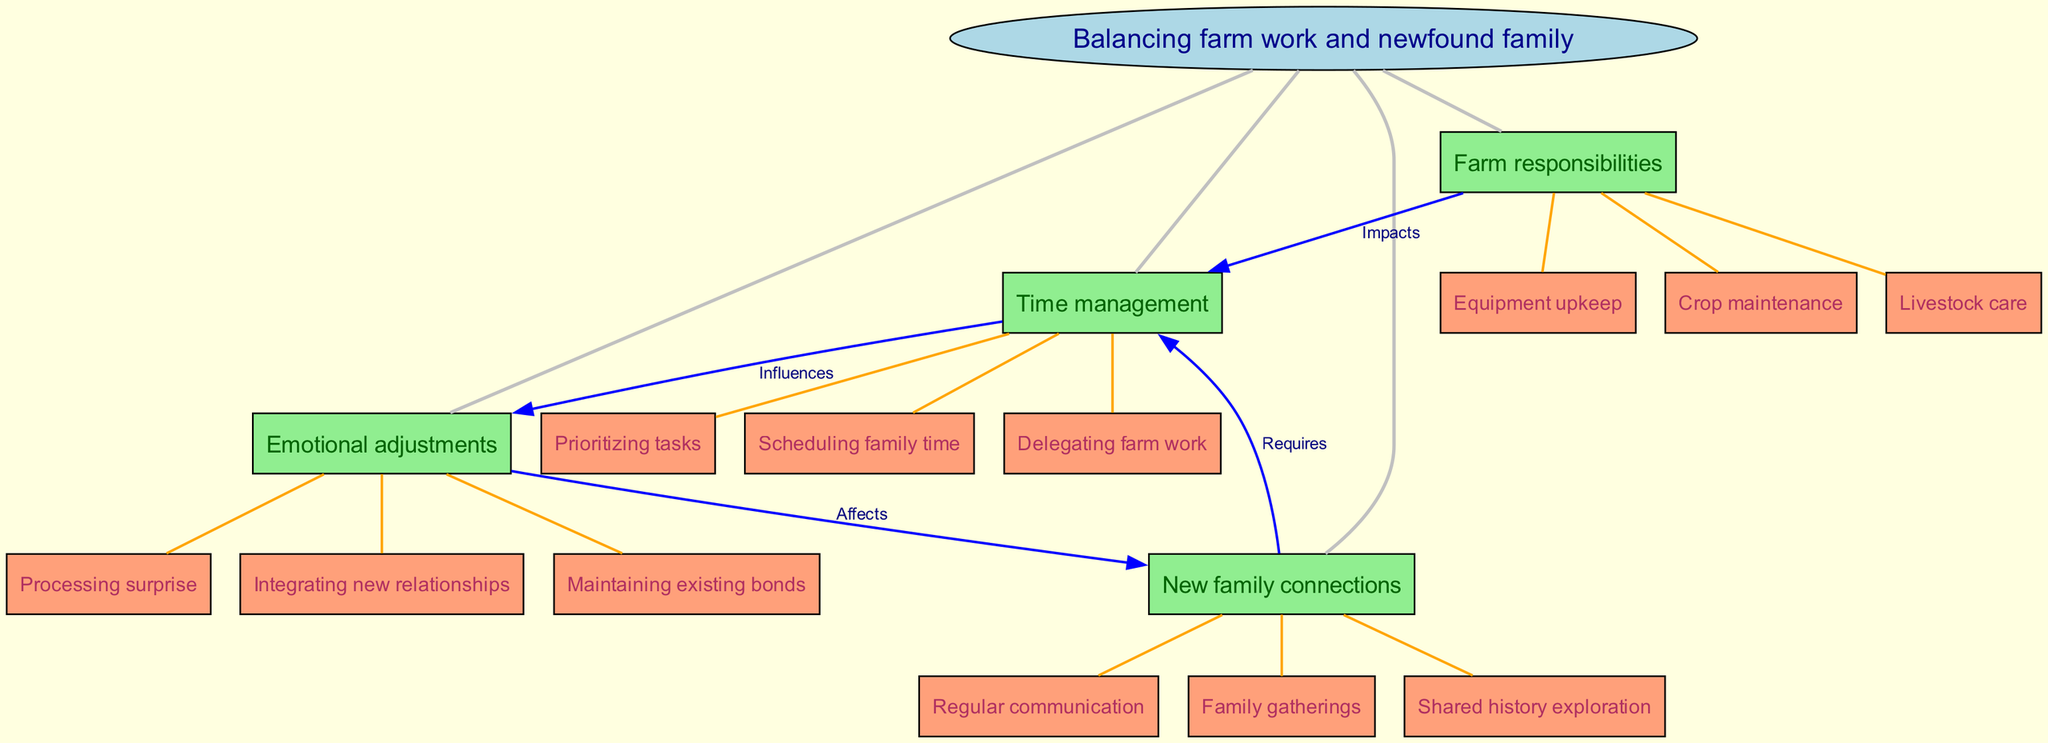What is the central concept of the diagram? The central concept is labeled "Balancing farm work and newfound family." This is specifically the node that is in the center of the diagram, connecting to the main themes of the concept map.
Answer: Balancing farm work and newfound family How many main nodes are present in the diagram? There are four main nodes connected to the central concept. By counting the distinct main nodes listed around the central concept, we can determine the number.
Answer: 4 Which main node is directly connected to "Crop maintenance"? The sub-node "Crop maintenance" is connected to the main node "Farm responsibilities." To identify this, we look at the subdivisions of each main node and find which main node houses that sub-node.
Answer: Farm responsibilities What relationship is indicated between "New family connections" and "Time management"? The relationship indicated is labeled "Requires." This means that new family connections necessitate time management, as shown by the directed edge between these two nodes in the diagram.
Answer: Requires How does "Time management" influence "Emotional adjustments"? The diagram shows a directed relationship labeled "Influences" that connects "Time management" to "Emotional adjustments." This means that effective time management will affect how emotional adjustments are made regarding family dynamics.
Answer: Influences What are the two sub-nodes listed under "Emotional adjustments"? The sub-nodes listed under "Emotional adjustments" are "Processing surprise" and "Integrating new relationships." By examining the cluster of sub-nodes under this main node, I can specify the content.
Answer: Processing surprise, Integrating new relationships Which main node is connected to the most sub-nodes in the diagram? The "Farm responsibilities" main node has three sub-nodes connected to it: "Crop maintenance," "Livestock care," and "Equipment upkeep," making it the main node with the most sub-nodes.
Answer: Farm responsibilities What are the impacts of "Farm responsibilities" on "Time management"? The relationship labeled "Impacts" indicates that the demands of farm responsibilities affect how time is managed. By following the arrows in the diagram, we can see this direct influence.
Answer: Impacts How does "Emotional adjustments" affect "New family connections"? The diagram denotes that "Emotional adjustments" "Affects" "New family connections." This means that the processes of emotional adjustment will have an effect on how those new family relationships develop and are maintained.
Answer: Affects 